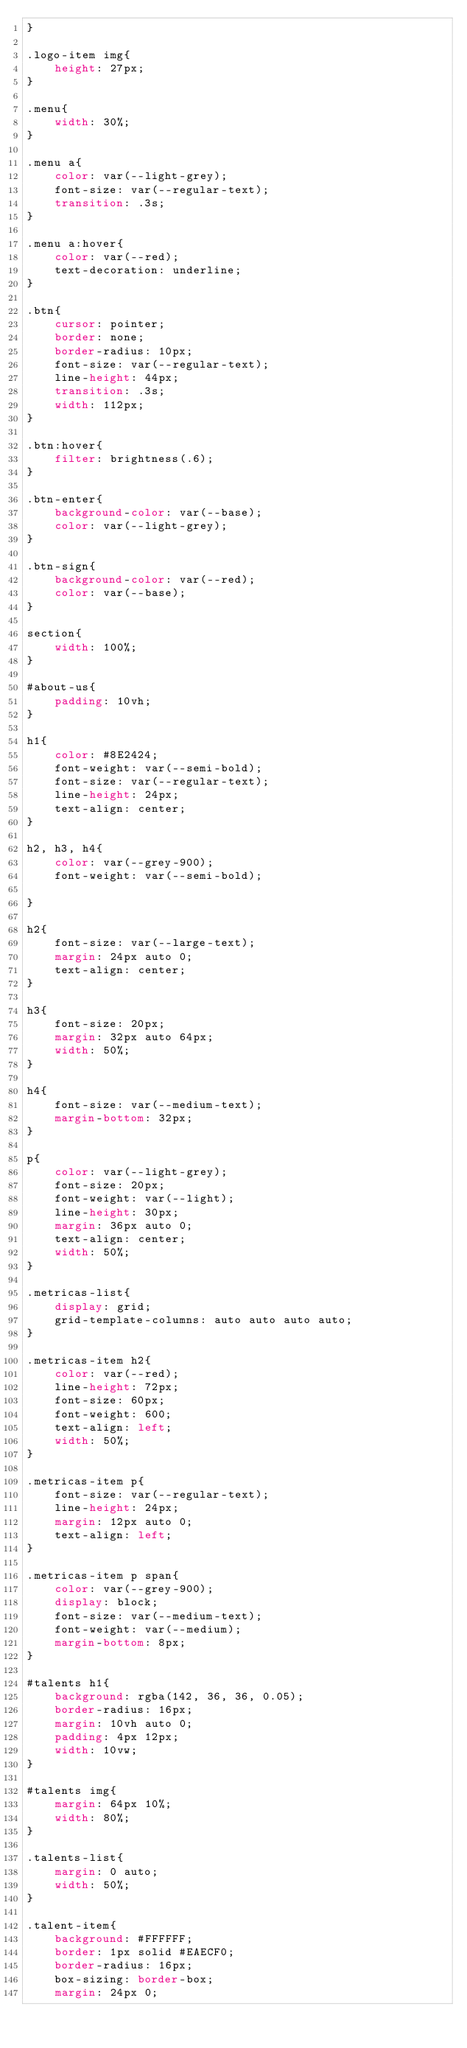Convert code to text. <code><loc_0><loc_0><loc_500><loc_500><_CSS_>}

.logo-item img{
    height: 27px;
}

.menu{
    width: 30%;
}

.menu a{
    color: var(--light-grey);
    font-size: var(--regular-text);
    transition: .3s;
}

.menu a:hover{
    color: var(--red);
    text-decoration: underline;
}

.btn{
    cursor: pointer;
    border: none;
    border-radius: 10px;
    font-size: var(--regular-text);
    line-height: 44px;
    transition: .3s;
    width: 112px;
}

.btn:hover{
    filter: brightness(.6);
}

.btn-enter{
    background-color: var(--base);
    color: var(--light-grey);
}

.btn-sign{
    background-color: var(--red);
    color: var(--base);
}

section{
    width: 100%;
}

#about-us{
    padding: 10vh;
}

h1{
    color: #8E2424;
    font-weight: var(--semi-bold);
    font-size: var(--regular-text);
    line-height: 24px;
    text-align: center;
}

h2, h3, h4{
    color: var(--grey-900);
    font-weight: var(--semi-bold);
    
}

h2{
    font-size: var(--large-text);
    margin: 24px auto 0;
    text-align: center;
}

h3{
    font-size: 20px;
    margin: 32px auto 64px;
    width: 50%;
}

h4{
    font-size: var(--medium-text);
    margin-bottom: 32px;
}

p{
    color: var(--light-grey);
    font-size: 20px;
    font-weight: var(--light);
    line-height: 30px;
    margin: 36px auto 0;
    text-align: center;
    width: 50%;
}

.metricas-list{
    display: grid;
    grid-template-columns: auto auto auto auto;
}

.metricas-item h2{
    color: var(--red);
    line-height: 72px;
    font-size: 60px;
    font-weight: 600;
    text-align: left;
    width: 50%;
}

.metricas-item p{
    font-size: var(--regular-text);
    line-height: 24px;
    margin: 12px auto 0;
    text-align: left;
}

.metricas-item p span{
    color: var(--grey-900);
    display: block;
    font-size: var(--medium-text);
    font-weight: var(--medium);
    margin-bottom: 8px;
}

#talents h1{
    background: rgba(142, 36, 36, 0.05);
    border-radius: 16px;
    margin: 10vh auto 0;
    padding: 4px 12px;
    width: 10vw;
}

#talents img{
    margin: 64px 10%;
    width: 80%;
}

.talents-list{
    margin: 0 auto;
    width: 50%;
}

.talent-item{
    background: #FFFFFF;
    border: 1px solid #EAECF0;
    border-radius: 16px;
    box-sizing: border-box;
    margin: 24px 0;</code> 